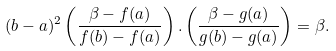<formula> <loc_0><loc_0><loc_500><loc_500>( b - a ) ^ { 2 } \left ( \frac { \beta - f ( a ) } { f ( b ) - f ( a ) } \right ) . \left ( \frac { \beta - g ( a ) } { g ( b ) - g ( a ) } \right ) = \beta .</formula> 